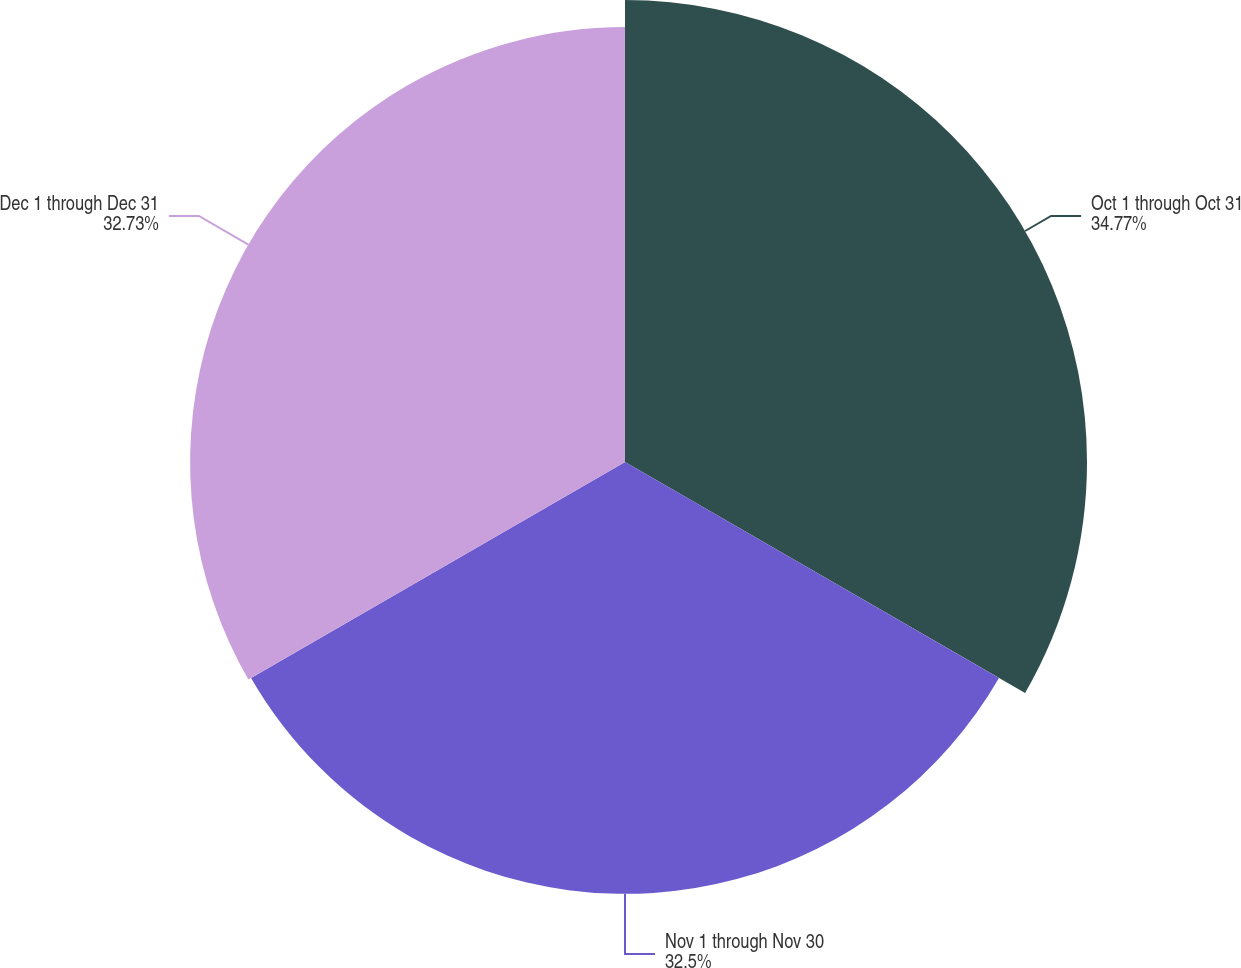Convert chart to OTSL. <chart><loc_0><loc_0><loc_500><loc_500><pie_chart><fcel>Oct 1 through Oct 31<fcel>Nov 1 through Nov 30<fcel>Dec 1 through Dec 31<nl><fcel>34.77%<fcel>32.5%<fcel>32.73%<nl></chart> 